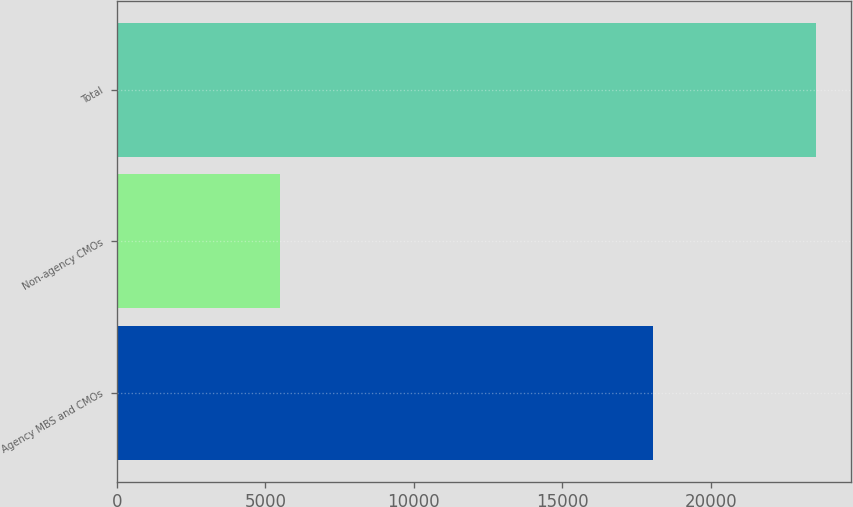<chart> <loc_0><loc_0><loc_500><loc_500><bar_chart><fcel>Agency MBS and CMOs<fcel>Non-agency CMOs<fcel>Total<nl><fcel>18062<fcel>5506<fcel>23568<nl></chart> 